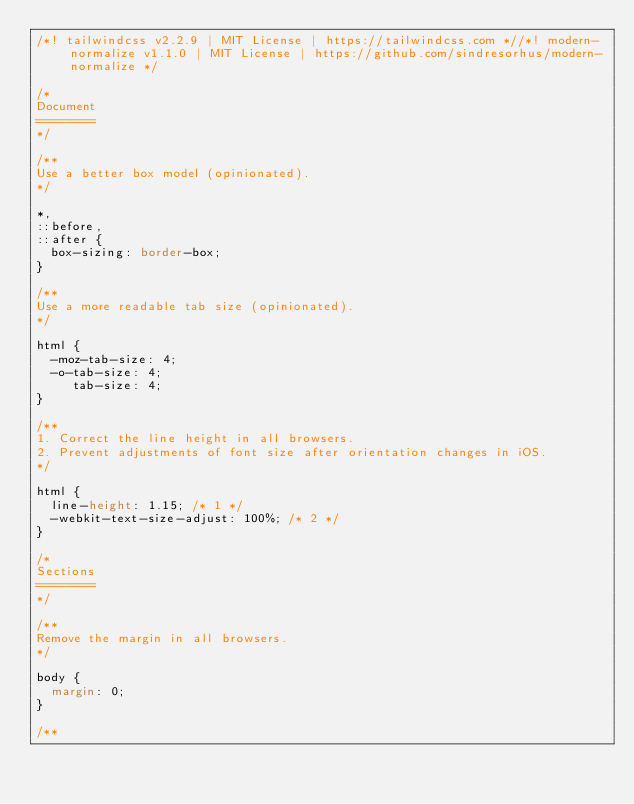<code> <loc_0><loc_0><loc_500><loc_500><_CSS_>/*! tailwindcss v2.2.9 | MIT License | https://tailwindcss.com *//*! modern-normalize v1.1.0 | MIT License | https://github.com/sindresorhus/modern-normalize */

/*
Document
========
*/

/**
Use a better box model (opinionated).
*/

*,
::before,
::after {
	box-sizing: border-box;
}

/**
Use a more readable tab size (opinionated).
*/

html {
	-moz-tab-size: 4;
	-o-tab-size: 4;
	   tab-size: 4;
}

/**
1. Correct the line height in all browsers.
2. Prevent adjustments of font size after orientation changes in iOS.
*/

html {
	line-height: 1.15; /* 1 */
	-webkit-text-size-adjust: 100%; /* 2 */
}

/*
Sections
========
*/

/**
Remove the margin in all browsers.
*/

body {
	margin: 0;
}

/**</code> 